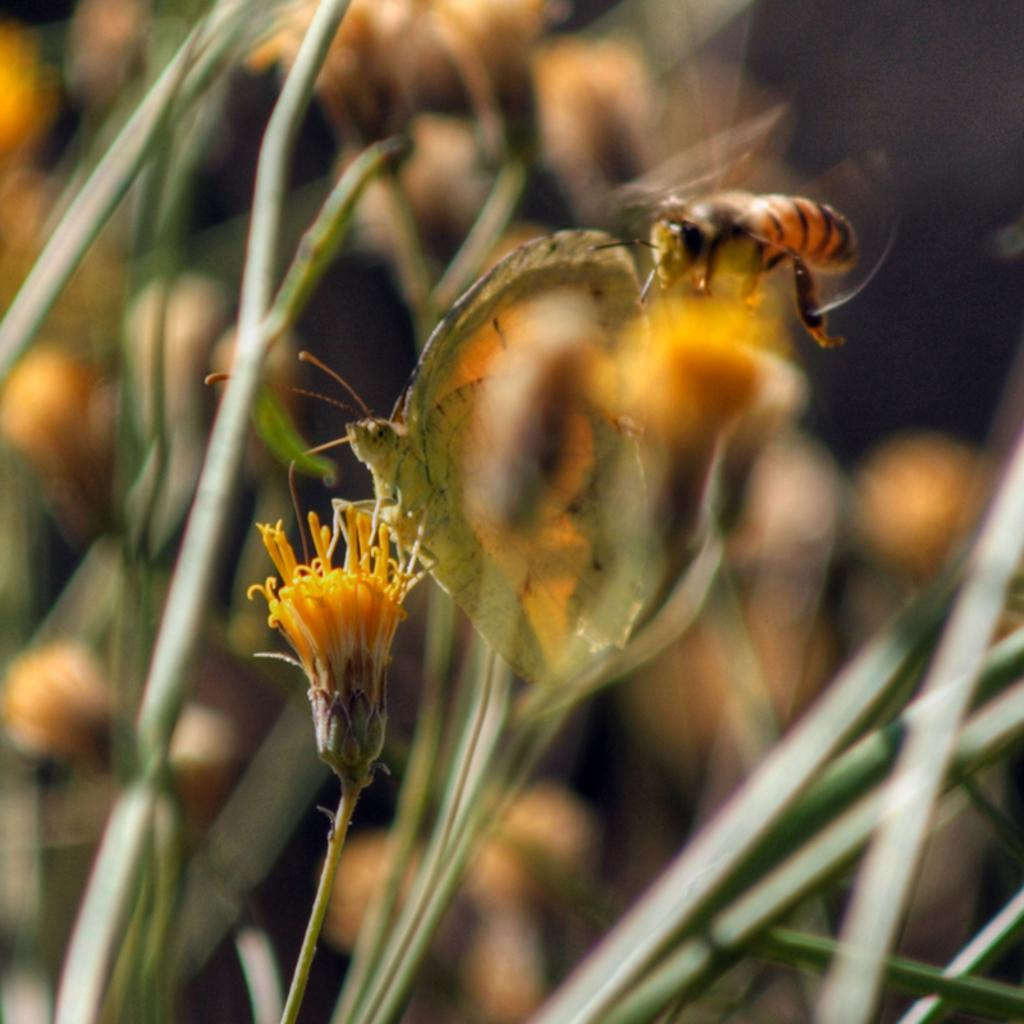What is the main subject of the image? The main subject of the image is plants and flowers. What color are the plants and flowers in the image? The plants and flowers are in yellow color. Can you describe any living organisms present in the image? Yes, there is an insect on one of the flowers. How would you describe the background of the image? The background of the image is blurred. How many jellyfish can be seen swimming in the image? There are no jellyfish present in the image; it features plants and flowers with an insect. Can you tell me the breed of the rabbit in the image? There is no rabbit present in the image. 